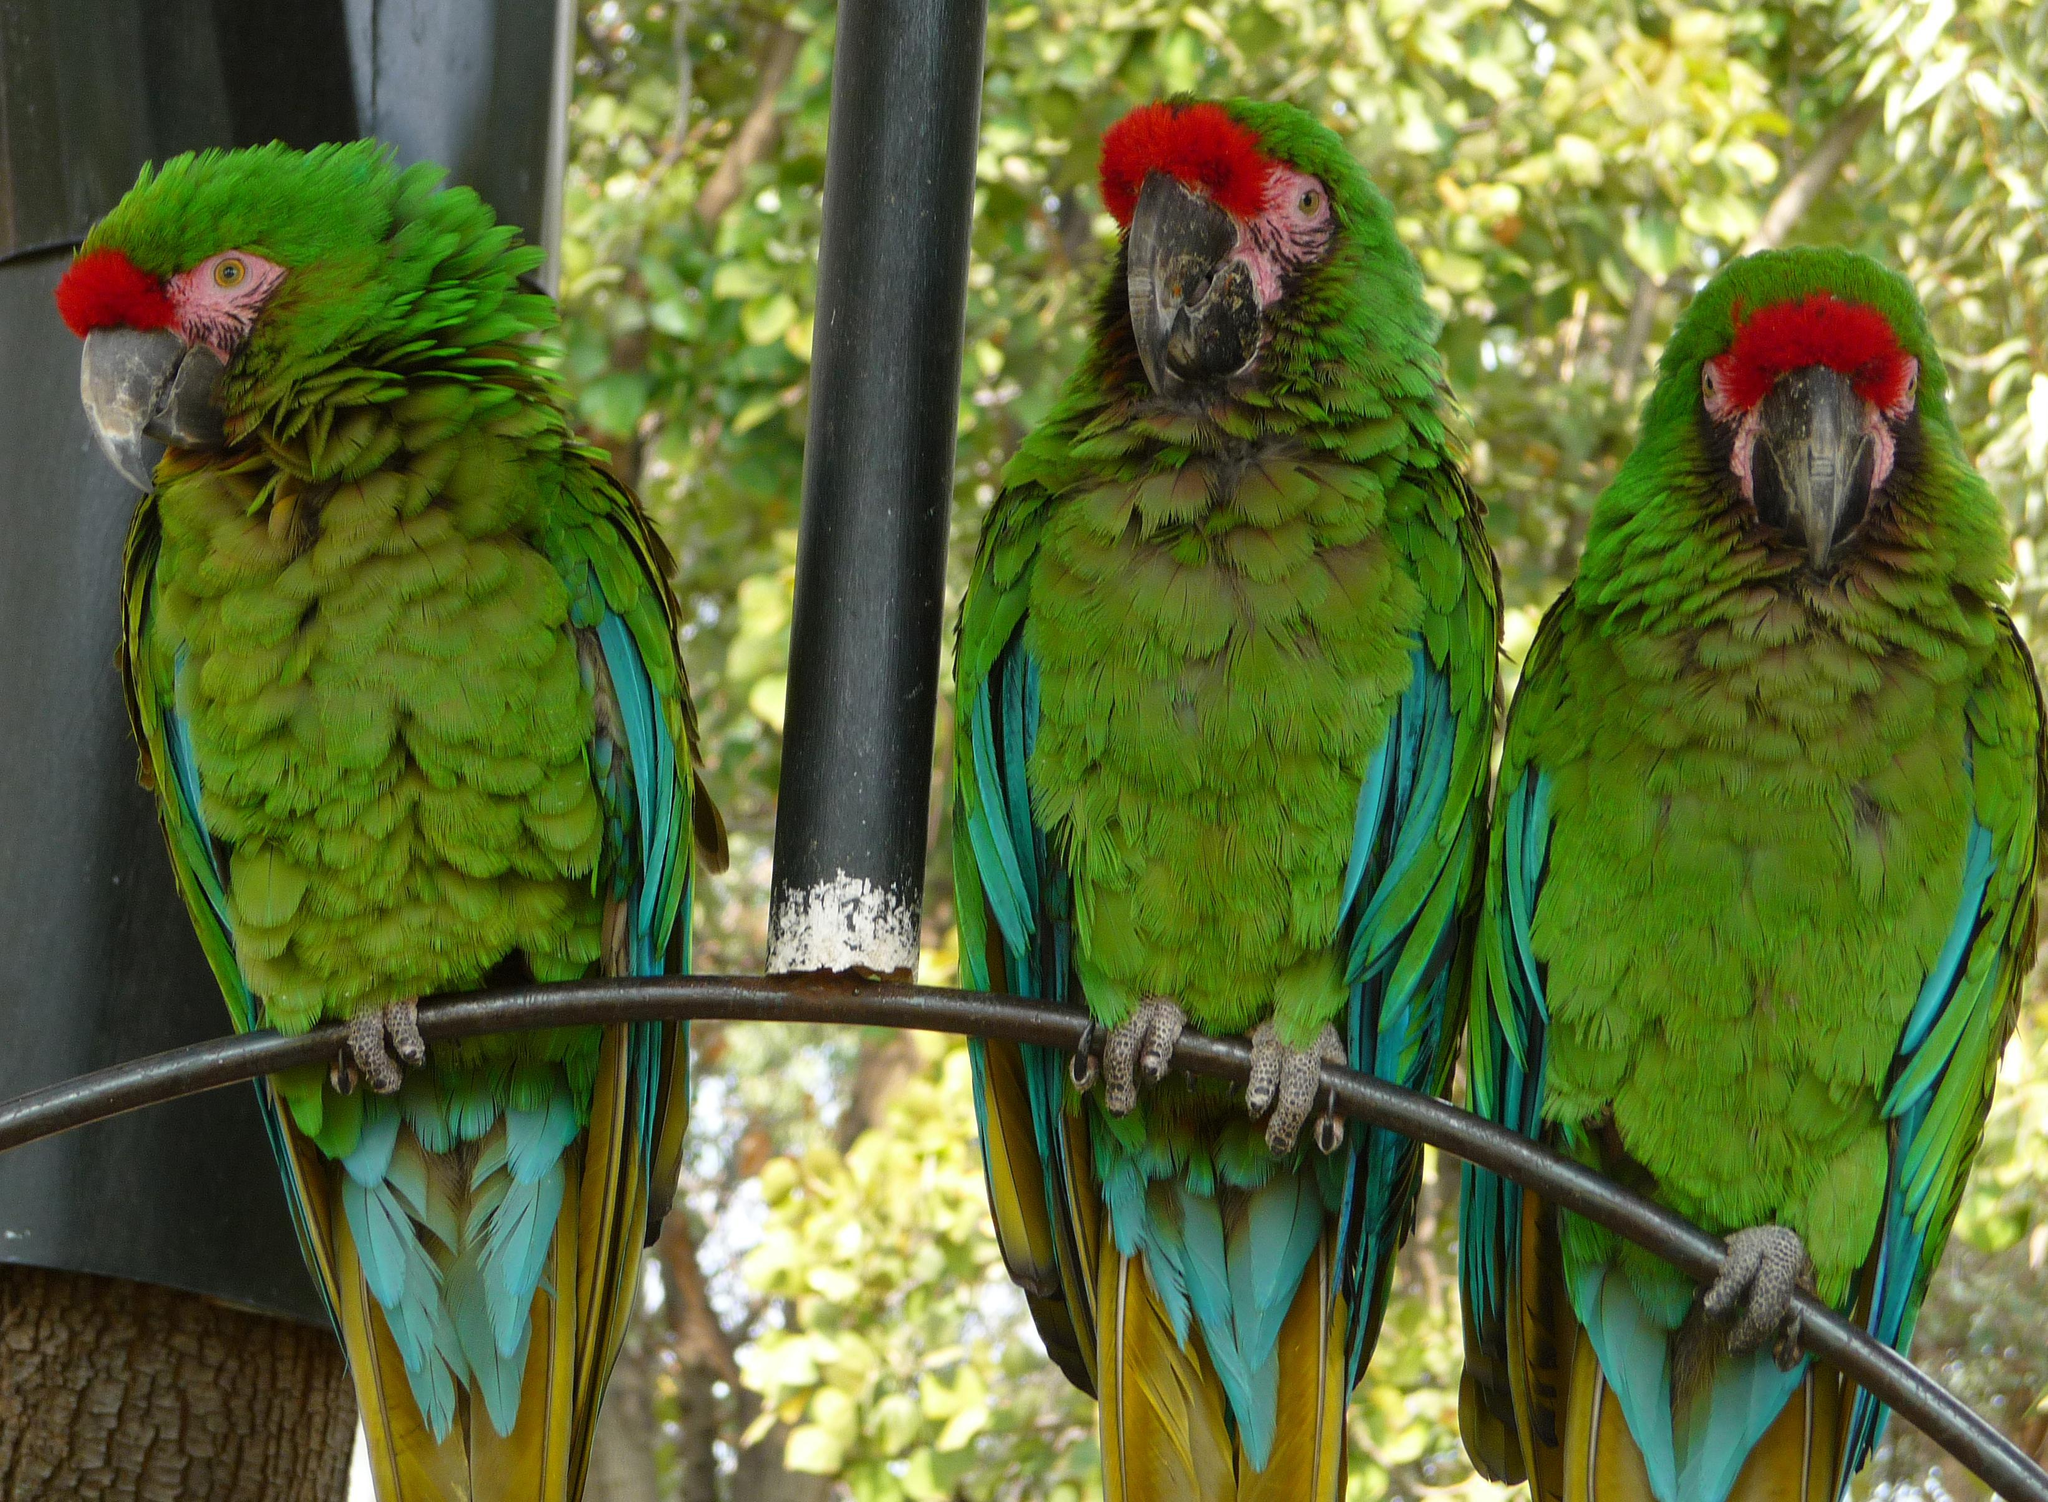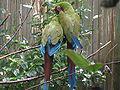The first image is the image on the left, the second image is the image on the right. Analyze the images presented: Is the assertion "In one image two parrots are standing on a branch and in the other there's only one parrot" valid? Answer yes or no. No. The first image is the image on the left, the second image is the image on the right. Given the left and right images, does the statement "There are at most 3 parrots." hold true? Answer yes or no. No. 